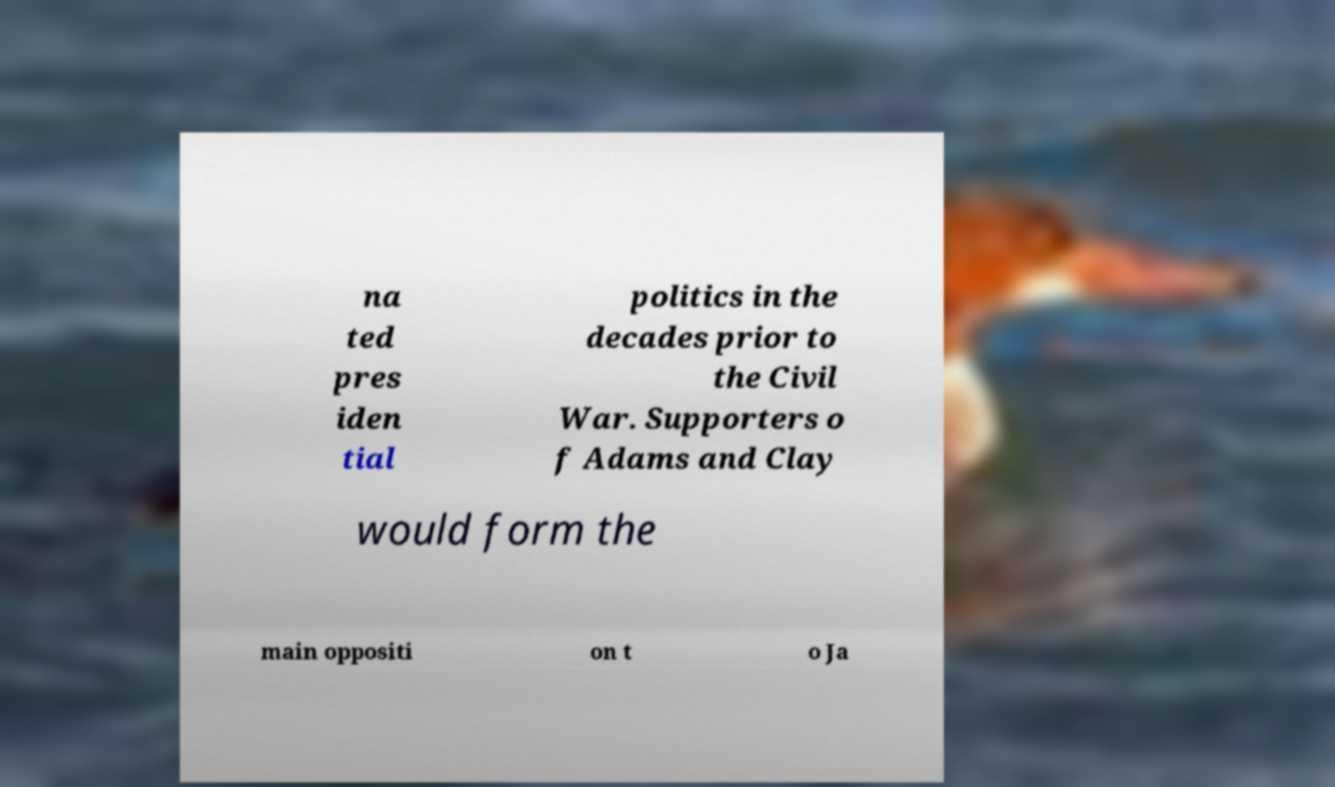Can you read and provide the text displayed in the image?This photo seems to have some interesting text. Can you extract and type it out for me? na ted pres iden tial politics in the decades prior to the Civil War. Supporters o f Adams and Clay would form the main oppositi on t o Ja 